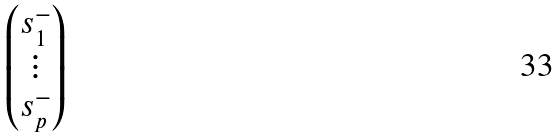<formula> <loc_0><loc_0><loc_500><loc_500>\begin{pmatrix} s _ { 1 } ^ { - } \\ \vdots \\ s _ { p } ^ { - } \end{pmatrix}</formula> 